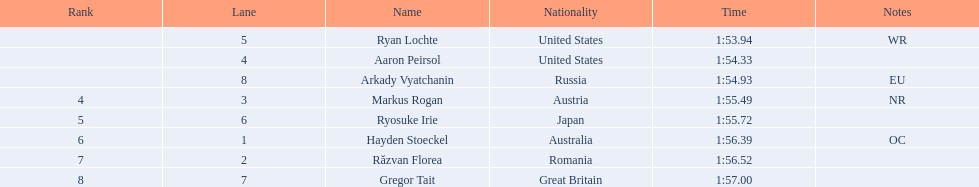Who engaged in the happening? Ryan Lochte, Aaron Peirsol, Arkady Vyatchanin, Markus Rogan, Ryosuke Irie, Hayden Stoeckel, Răzvan Florea, Gregor Tait. What were the final times for all athletes? 1:53.94, 1:54.33, 1:54.93, 1:55.49, 1:55.72, 1:56.39, 1:56.52, 1:57.00. What about merely ryosuke irie? 1:55.72. 